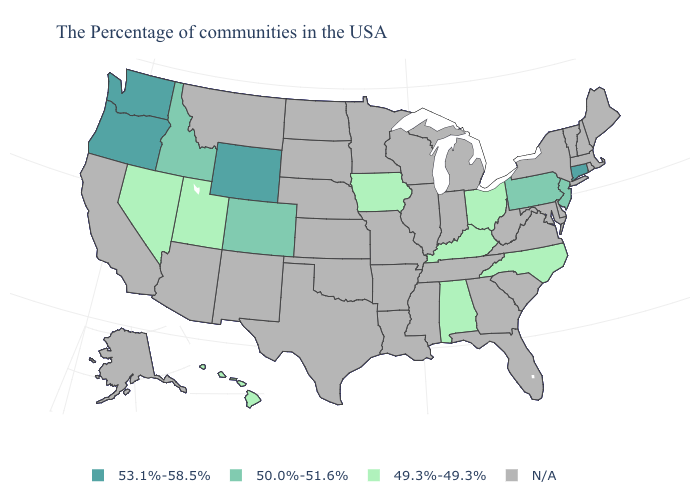Which states have the highest value in the USA?
Short answer required. Connecticut, Wyoming, Washington, Oregon. What is the value of Oregon?
Be succinct. 53.1%-58.5%. What is the value of Iowa?
Answer briefly. 49.3%-49.3%. Does Washington have the highest value in the USA?
Be succinct. Yes. Is the legend a continuous bar?
Write a very short answer. No. How many symbols are there in the legend?
Write a very short answer. 4. Among the states that border Nevada , which have the highest value?
Answer briefly. Oregon. What is the value of New York?
Concise answer only. N/A. Name the states that have a value in the range 53.1%-58.5%?
Be succinct. Connecticut, Wyoming, Washington, Oregon. Name the states that have a value in the range 53.1%-58.5%?
Answer briefly. Connecticut, Wyoming, Washington, Oregon. Name the states that have a value in the range 53.1%-58.5%?
Be succinct. Connecticut, Wyoming, Washington, Oregon. Which states have the highest value in the USA?
Short answer required. Connecticut, Wyoming, Washington, Oregon. Name the states that have a value in the range 50.0%-51.6%?
Answer briefly. New Jersey, Pennsylvania, Colorado, Idaho. 